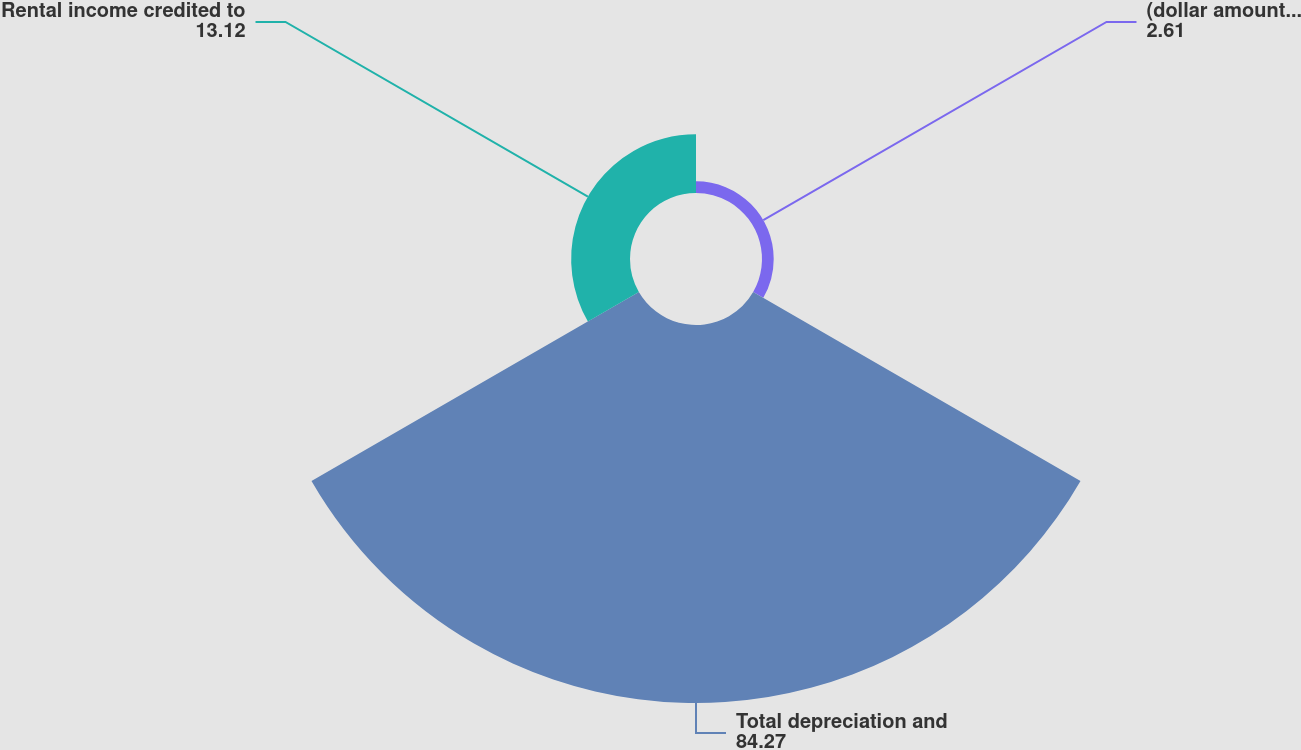Convert chart to OTSL. <chart><loc_0><loc_0><loc_500><loc_500><pie_chart><fcel>(dollar amounts in thousands)<fcel>Total depreciation and<fcel>Rental income credited to<nl><fcel>2.61%<fcel>84.27%<fcel>13.12%<nl></chart> 